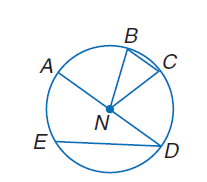Answer the mathemtical geometry problem and directly provide the correct option letter.
Question: If m \widehat B C = 30 and A B \cong \widehat C D, find m \widehat A B.
Choices: A: 75 B: 90 C: 105 D: 120 A 